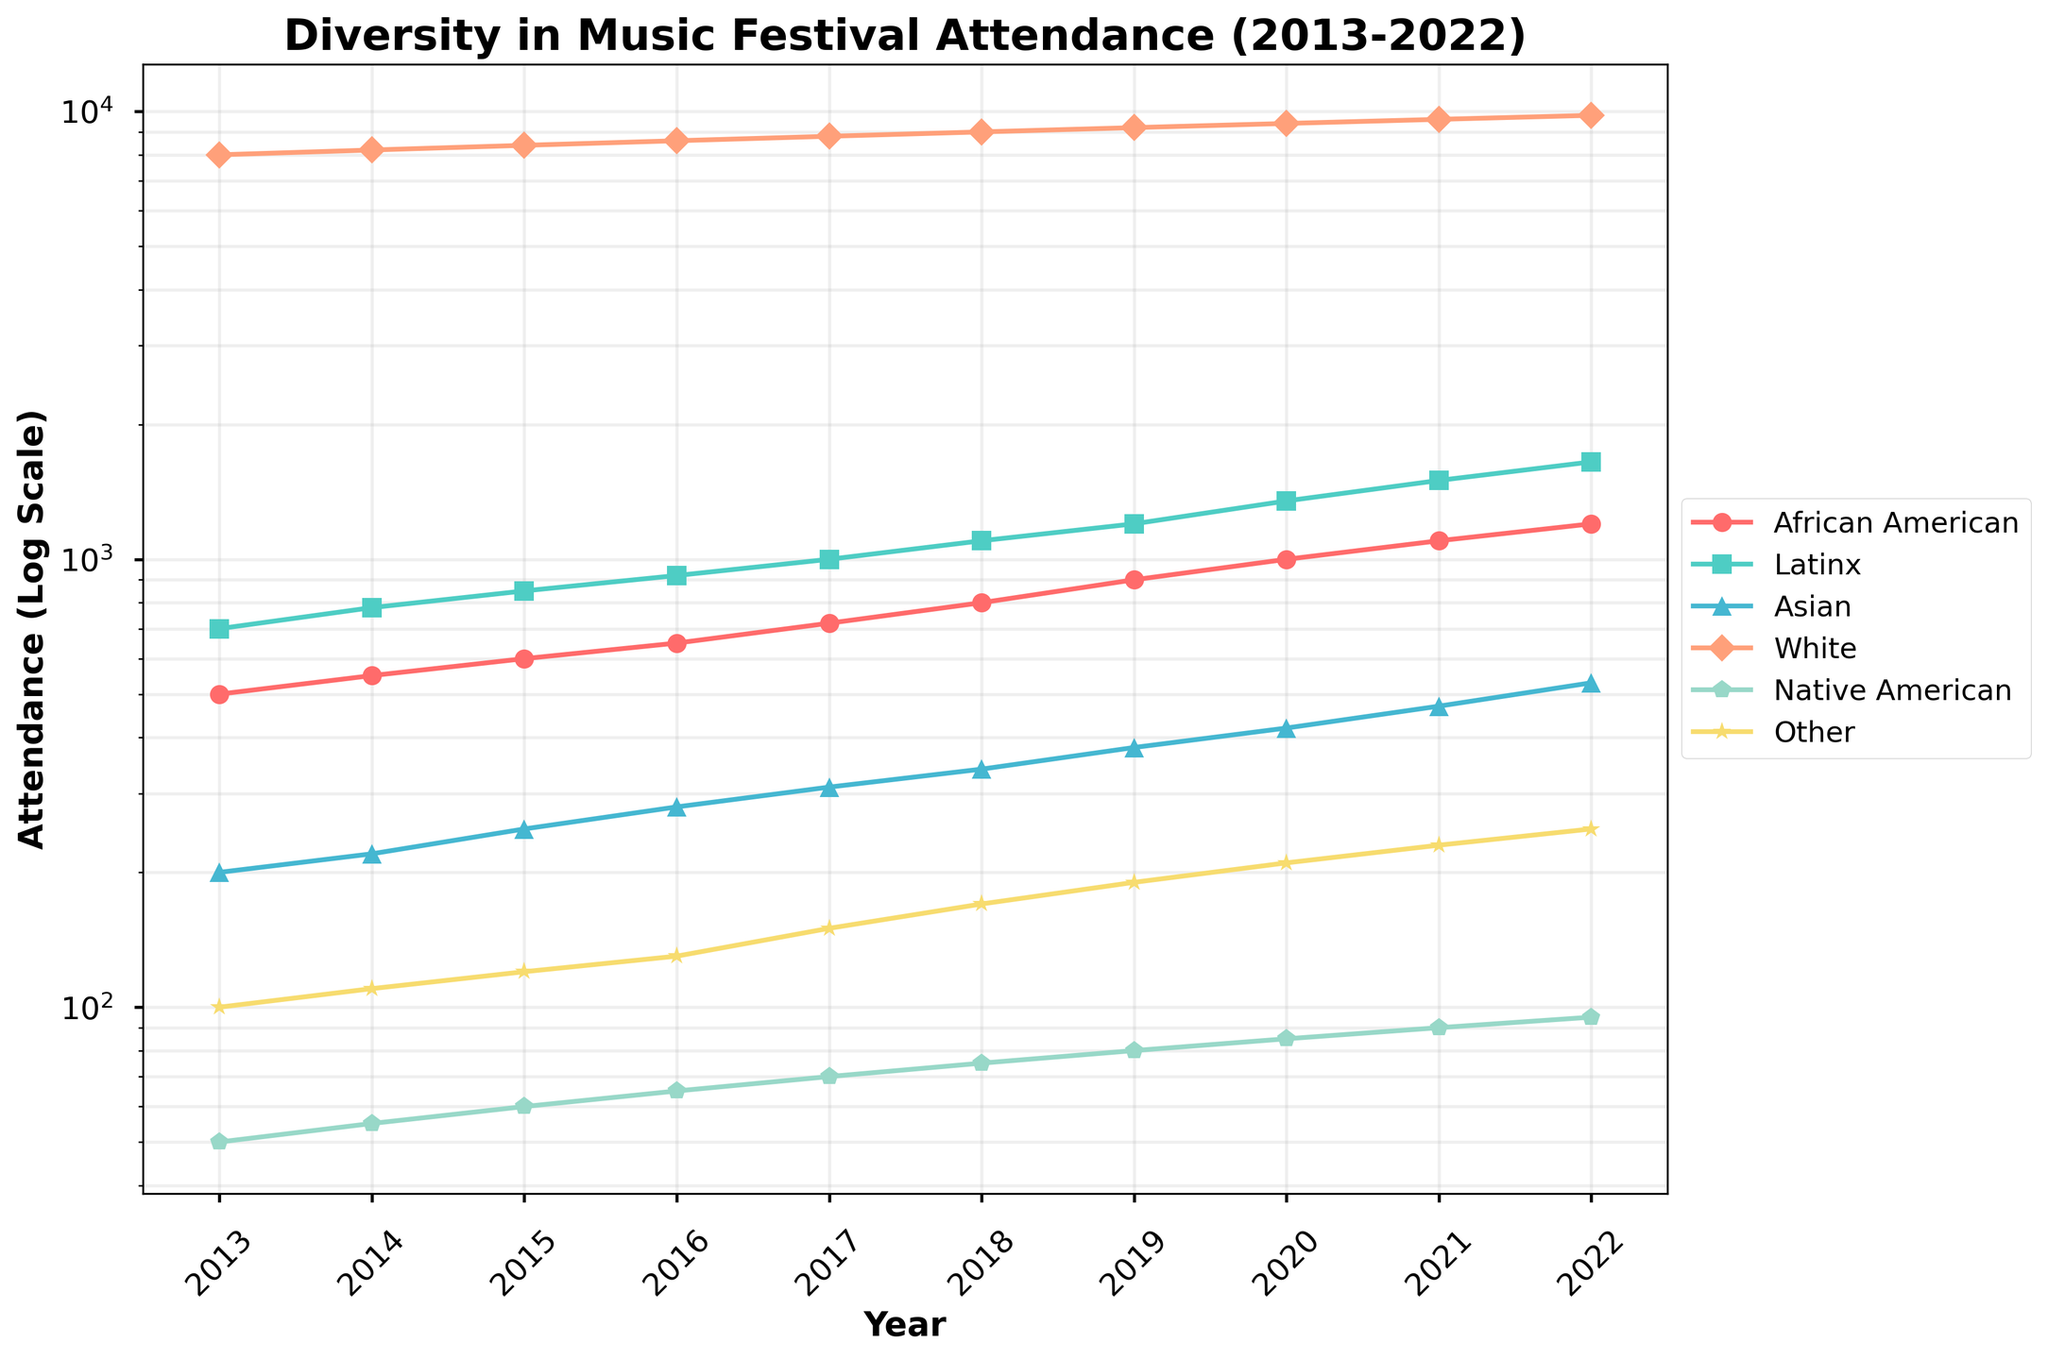Which cultural background had the highest attendance in 2017? The figure’s lines show the attendance values for various cultural backgrounds. In 2017, the 'White' category peaks highest.
Answer: White How has the attendance of the Native American group changed from 2013 to 2022? The Native American attendance line starts at 50 in 2013 and ends at 95 in 2022, indicating an increase.
Answer: Increased Which group's attendance exhibited the most significant increase from 2013 to 2022? By comparing all groups’ endpoints in 2022 to their start points in 2013, the 'Latinx' group shows the most dramatic rise from 700 to 1650.
Answer: Latinx What is the average attendance for the African American group over the decade? Summing the African American attendance numbers (500+550+600+650+720+800+900+1000+1100+1200) = 8020, then dividing by 10 years results in 802.
Answer: 802 Compare the attendance of the Asian and Other groups in 2022. Which is higher and by how much? In 2022, the Asian group's attendance is 530 and Other group’s is 250. Subtracting gives 530 - 250 = 280.
Answer: Asian is higher by 280 In which year did the Latinx attendance exceed 1000? The Latinx line crosses above 1000 in 2017.
Answer: 2017 What was the overall trend for the White group's attendance over the decade? Observing the line for the White group, it consistently increases from 8000 to 9800.
Answer: Increasing Calculate the total attendance for all groups in 2020. Summing up the values for each group in 2020: 1000 + 1350 + 420 + 9400 + 85 + 210 = 12465.
Answer: 12465 Which two groups have the closest attendance values in 2015? By looking at 2015 values, Asian (250) and Other (120) are the closest with a difference of 130.
Answer: Asian and Other Determine the median attendance for the Native American group over the decade. Listing Native American values: 50, 55, 60, 65, 70, 75, 80, 85, 90, 95. The median, being the middle of this ordered list, is (70+75)/2 = 72.5.
Answer: 72.5 